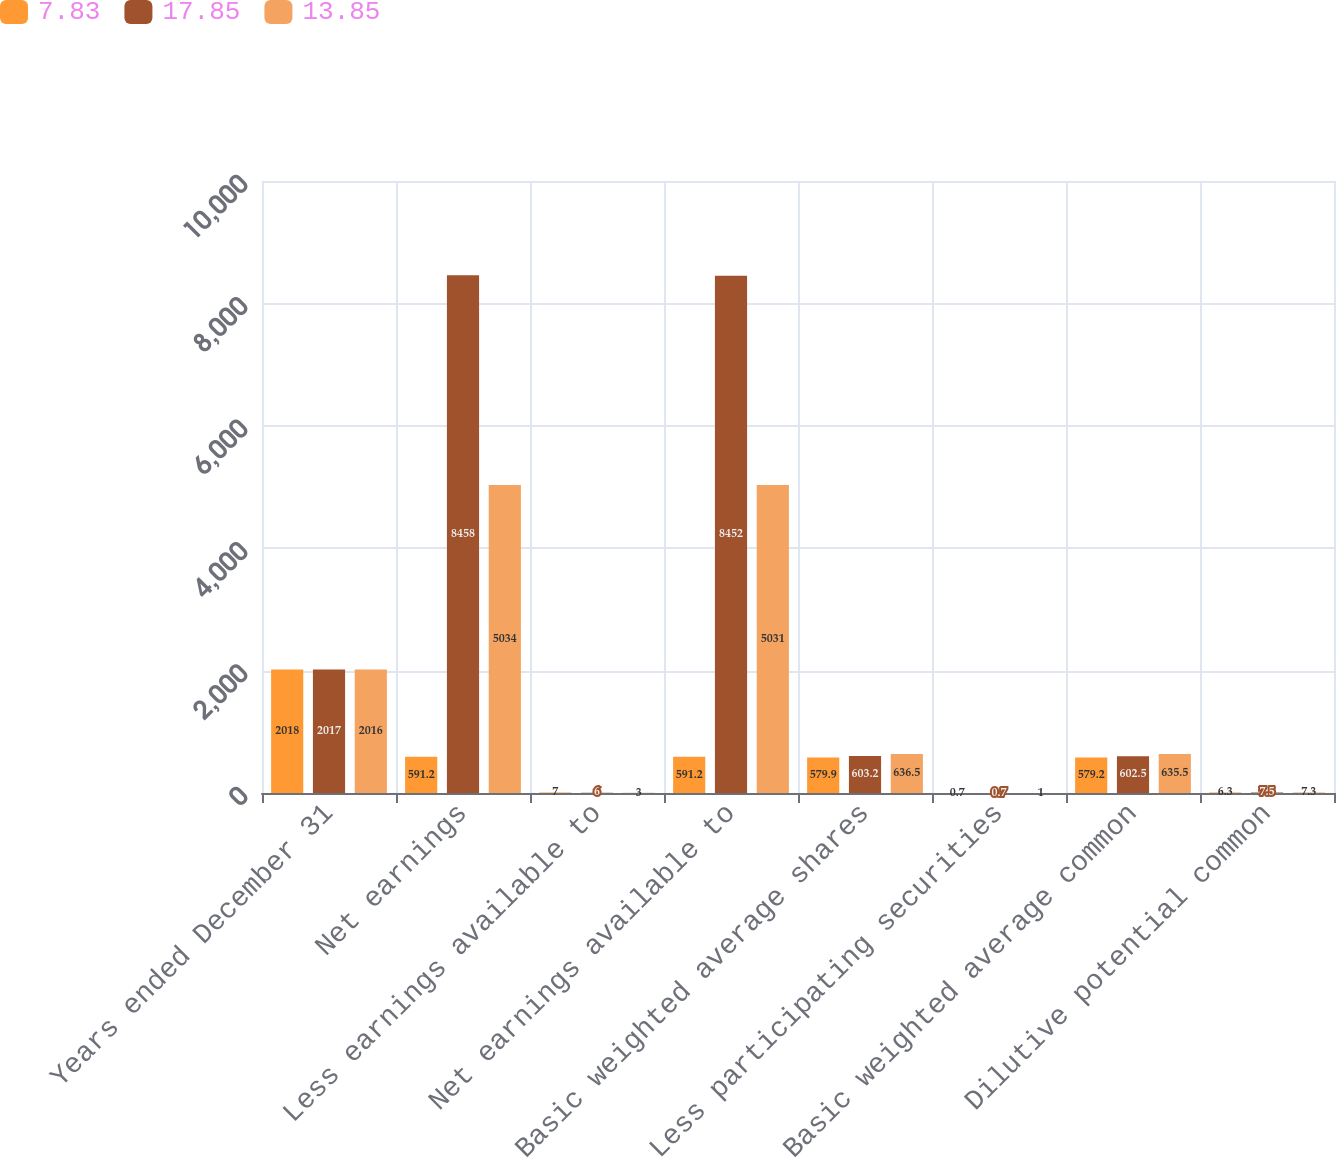Convert chart to OTSL. <chart><loc_0><loc_0><loc_500><loc_500><stacked_bar_chart><ecel><fcel>Years ended December 31<fcel>Net earnings<fcel>Less earnings available to<fcel>Net earnings available to<fcel>Basic weighted average shares<fcel>Less participating securities<fcel>Basic weighted average common<fcel>Dilutive potential common<nl><fcel>7.83<fcel>2018<fcel>591.2<fcel>7<fcel>591.2<fcel>579.9<fcel>0.7<fcel>579.2<fcel>6.3<nl><fcel>17.85<fcel>2017<fcel>8458<fcel>6<fcel>8452<fcel>603.2<fcel>0.7<fcel>602.5<fcel>7.5<nl><fcel>13.85<fcel>2016<fcel>5034<fcel>3<fcel>5031<fcel>636.5<fcel>1<fcel>635.5<fcel>7.3<nl></chart> 